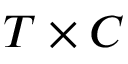Convert formula to latex. <formula><loc_0><loc_0><loc_500><loc_500>T \times C</formula> 